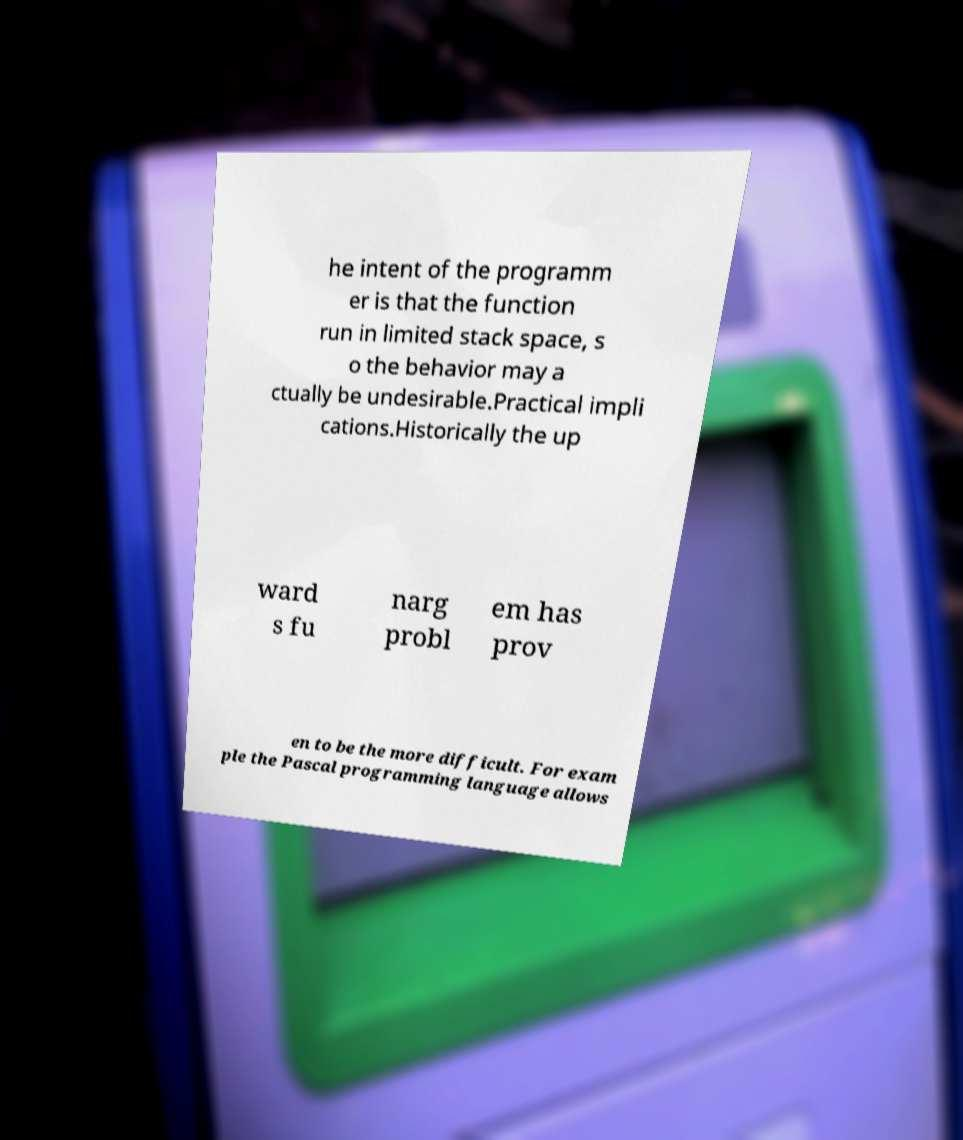Please read and relay the text visible in this image. What does it say? he intent of the programm er is that the function run in limited stack space, s o the behavior may a ctually be undesirable.Practical impli cations.Historically the up ward s fu narg probl em has prov en to be the more difficult. For exam ple the Pascal programming language allows 